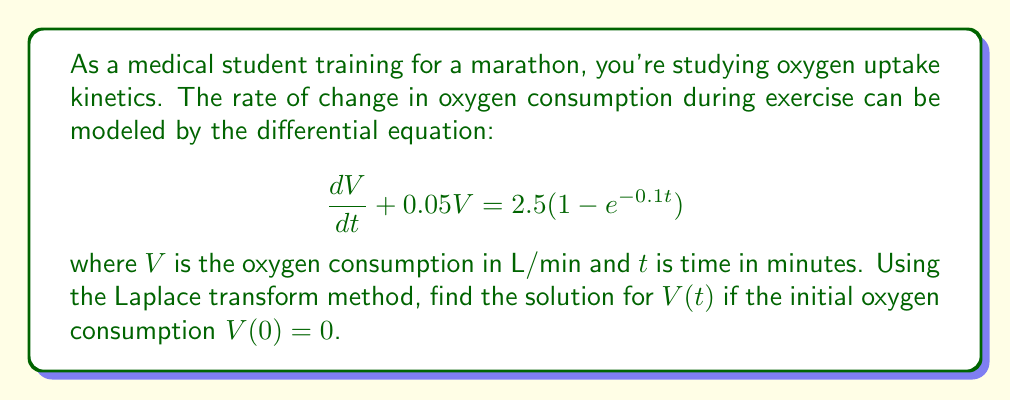Help me with this question. To solve this problem using the Laplace transform method, we'll follow these steps:

1) Take the Laplace transform of both sides of the equation:
   $$\mathcal{L}\left\{\frac{dV}{dt} + 0.05V\right\} = \mathcal{L}\left\{2.5(1-e^{-0.1t})\right\}$$

2) Using Laplace transform properties:
   $$sV(s) - V(0) + 0.05V(s) = \frac{2.5}{s} - \frac{2.5}{s+0.1}$$

3) Substitute $V(0) = 0$:
   $$sV(s) + 0.05V(s) = \frac{2.5}{s} - \frac{2.5}{s+0.1}$$

4) Factor out $V(s)$:
   $$V(s)(s + 0.05) = \frac{2.5}{s} - \frac{2.5}{s+0.1}$$

5) Solve for $V(s)$:
   $$V(s) = \frac{2.5}{s(s + 0.05)} - \frac{2.5}{(s+0.1)(s + 0.05)}$$

6) Use partial fraction decomposition:
   $$V(s) = \frac{A}{s} + \frac{B}{s + 0.05} - \frac{C}{s + 0.1} - \frac{D}{s + 0.05}$$

   where $A = 50$, $B = -50$, $C = 25$, and $D = -25$

7) Simplify:
   $$V(s) = \frac{50}{s} - \frac{25}{s + 0.05} - \frac{25}{s + 0.1}$$

8) Take the inverse Laplace transform:
   $$V(t) = 50 - 25e^{-0.05t} - 25e^{-0.1t}$$

This is the solution for $V(t)$, representing the oxygen consumption over time during the marathon training.
Answer: $V(t) = 50 - 25e^{-0.05t} - 25e^{-0.1t}$ 